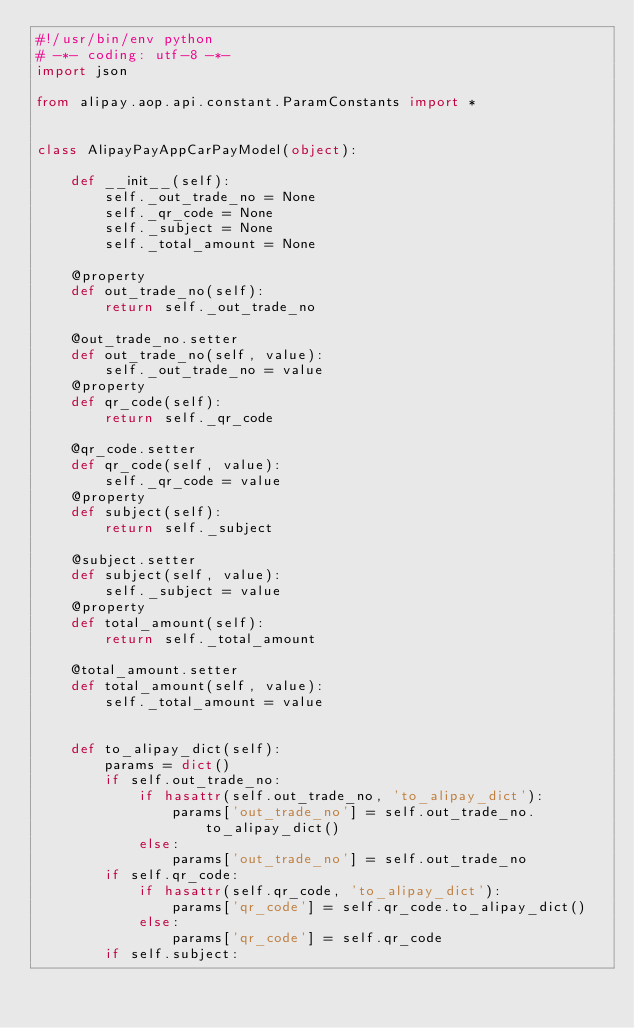Convert code to text. <code><loc_0><loc_0><loc_500><loc_500><_Python_>#!/usr/bin/env python
# -*- coding: utf-8 -*-
import json

from alipay.aop.api.constant.ParamConstants import *


class AlipayPayAppCarPayModel(object):

    def __init__(self):
        self._out_trade_no = None
        self._qr_code = None
        self._subject = None
        self._total_amount = None

    @property
    def out_trade_no(self):
        return self._out_trade_no

    @out_trade_no.setter
    def out_trade_no(self, value):
        self._out_trade_no = value
    @property
    def qr_code(self):
        return self._qr_code

    @qr_code.setter
    def qr_code(self, value):
        self._qr_code = value
    @property
    def subject(self):
        return self._subject

    @subject.setter
    def subject(self, value):
        self._subject = value
    @property
    def total_amount(self):
        return self._total_amount

    @total_amount.setter
    def total_amount(self, value):
        self._total_amount = value


    def to_alipay_dict(self):
        params = dict()
        if self.out_trade_no:
            if hasattr(self.out_trade_no, 'to_alipay_dict'):
                params['out_trade_no'] = self.out_trade_no.to_alipay_dict()
            else:
                params['out_trade_no'] = self.out_trade_no
        if self.qr_code:
            if hasattr(self.qr_code, 'to_alipay_dict'):
                params['qr_code'] = self.qr_code.to_alipay_dict()
            else:
                params['qr_code'] = self.qr_code
        if self.subject:</code> 